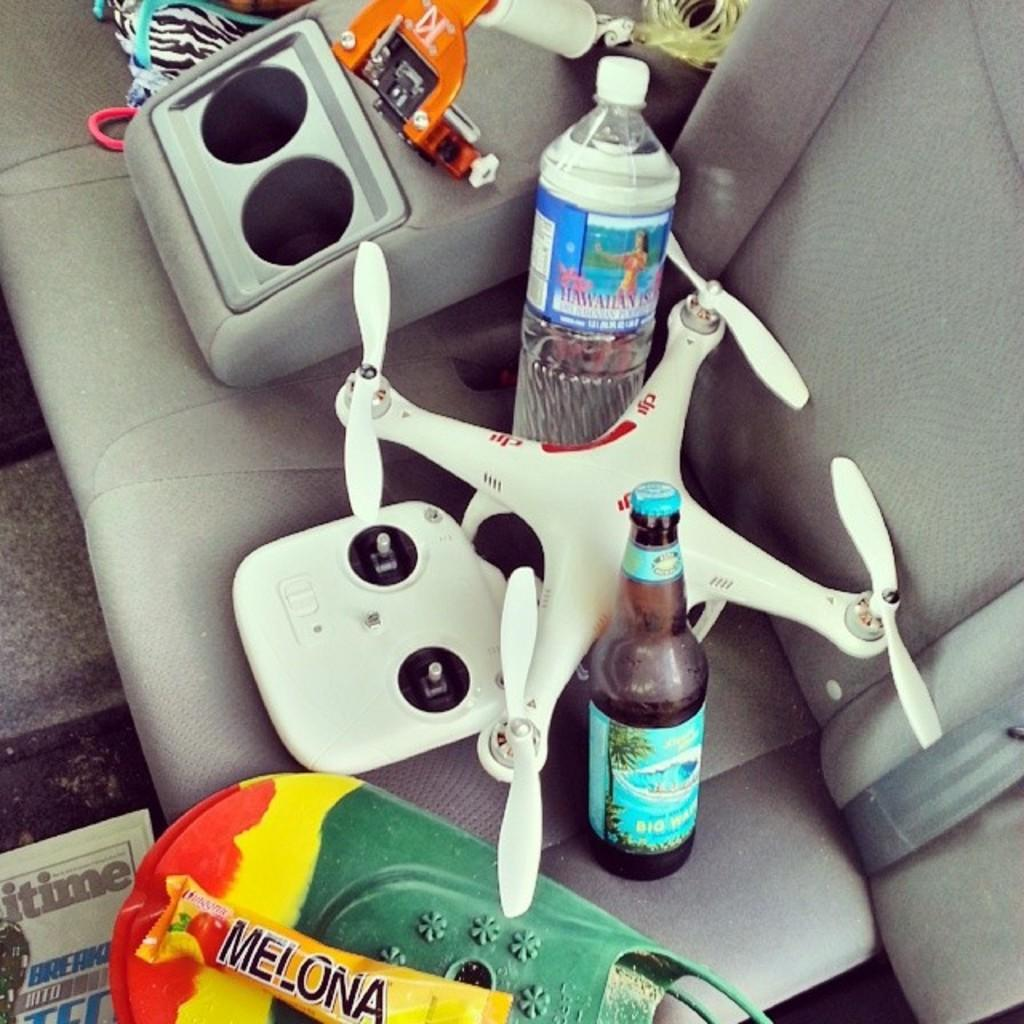Provide a one-sentence caption for the provided image. A red, yellow and green object has Melona in black letters. 